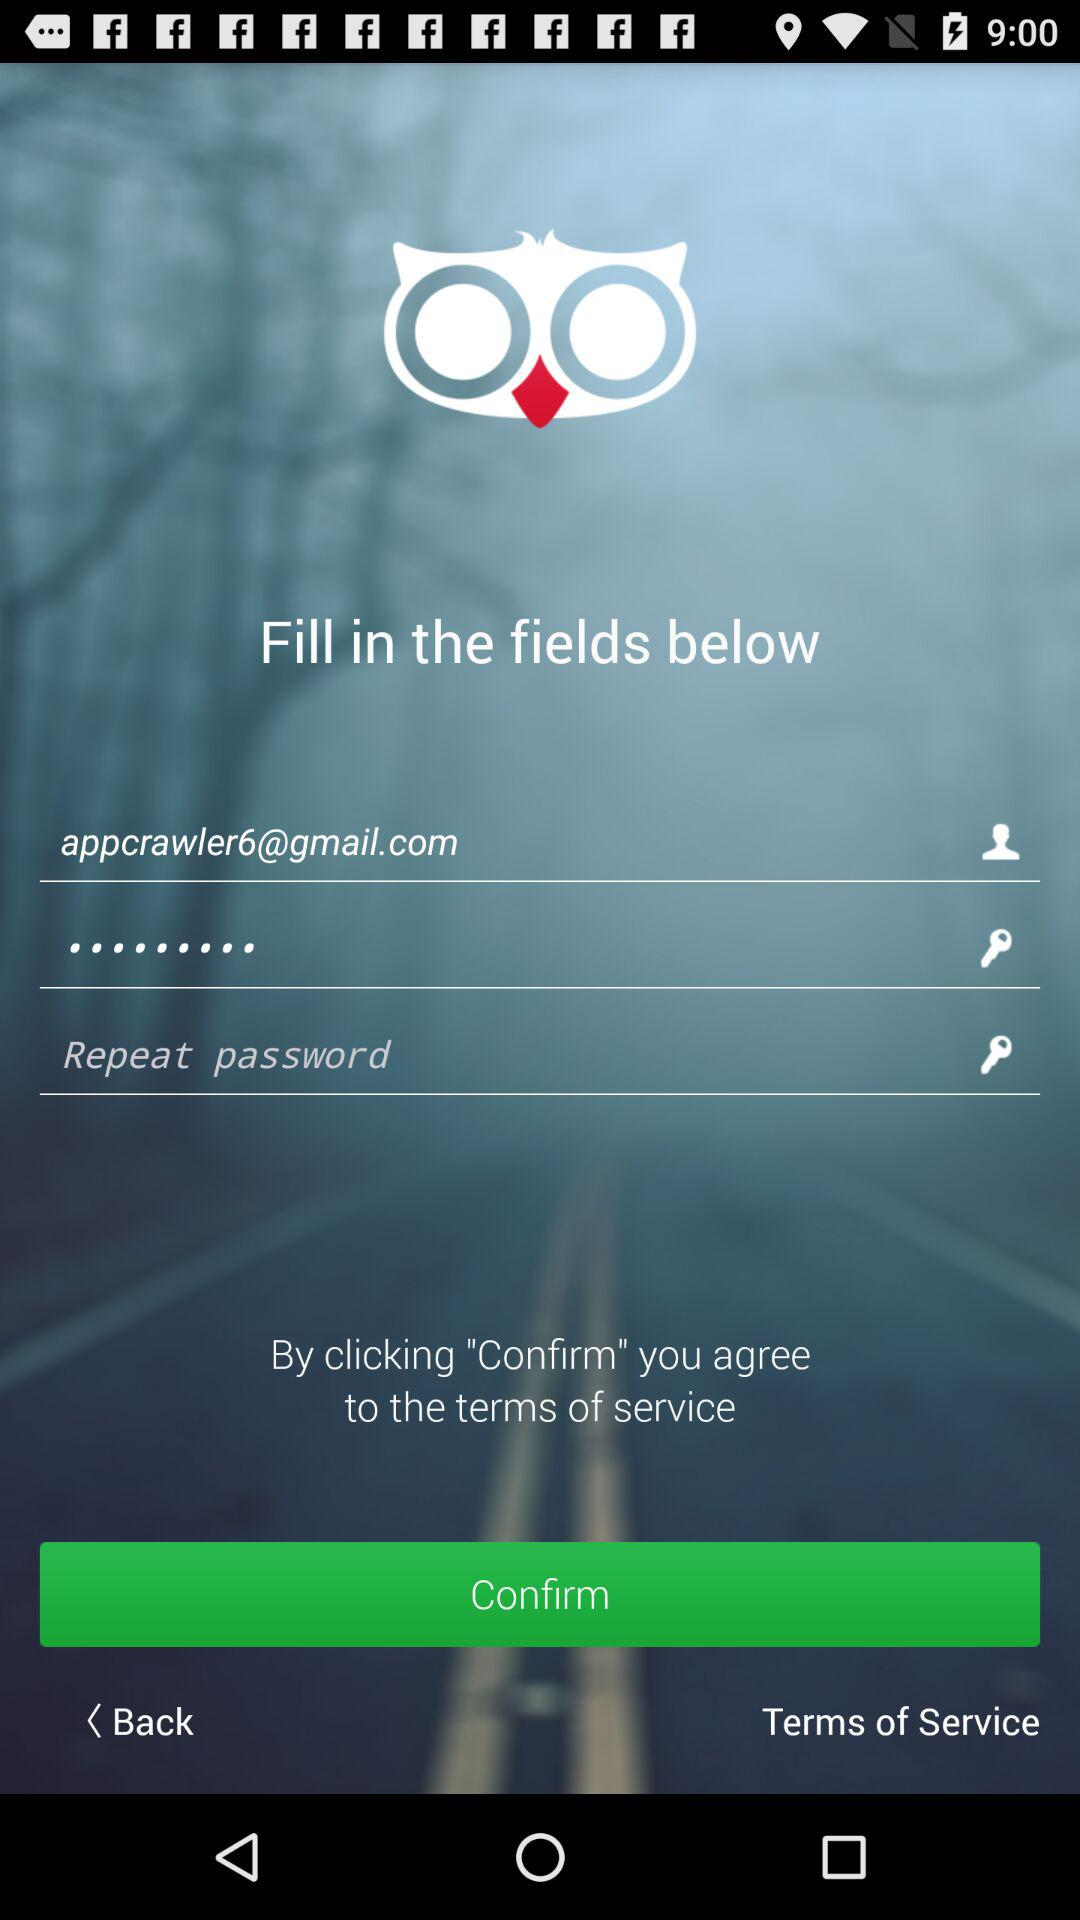What's the Google Mail address? The mail address is "appcrawler6@gmail.com". 